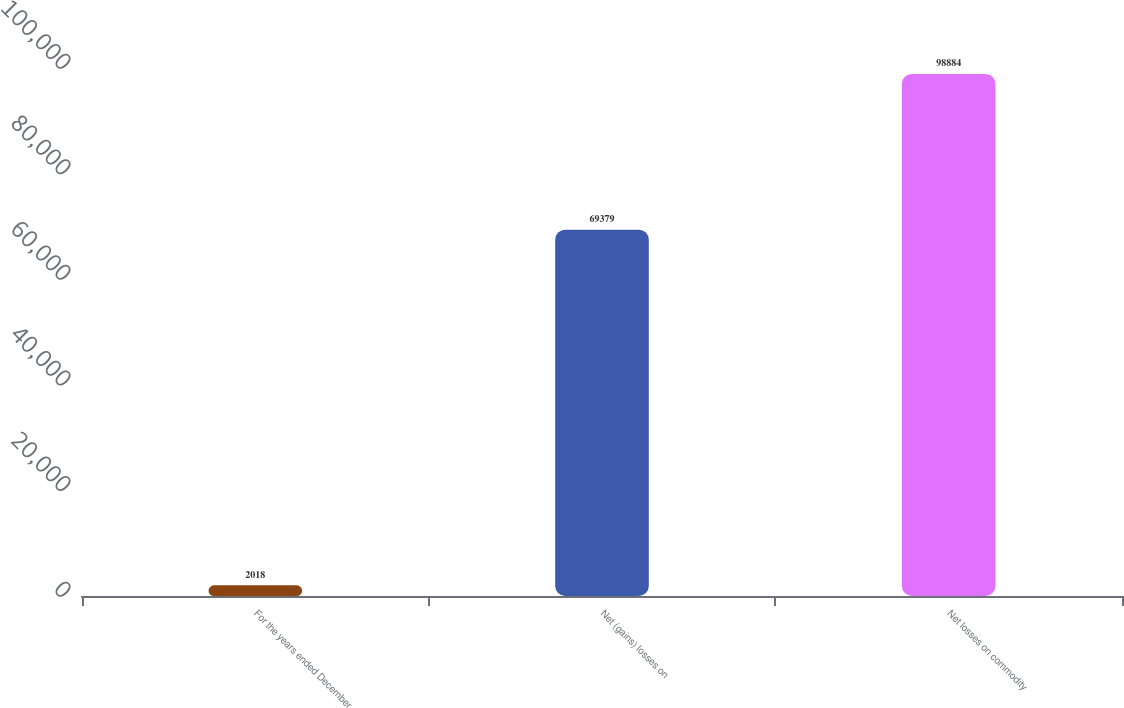<chart> <loc_0><loc_0><loc_500><loc_500><bar_chart><fcel>For the years ended December<fcel>Net (gains) losses on<fcel>Net losses on commodity<nl><fcel>2018<fcel>69379<fcel>98884<nl></chart> 